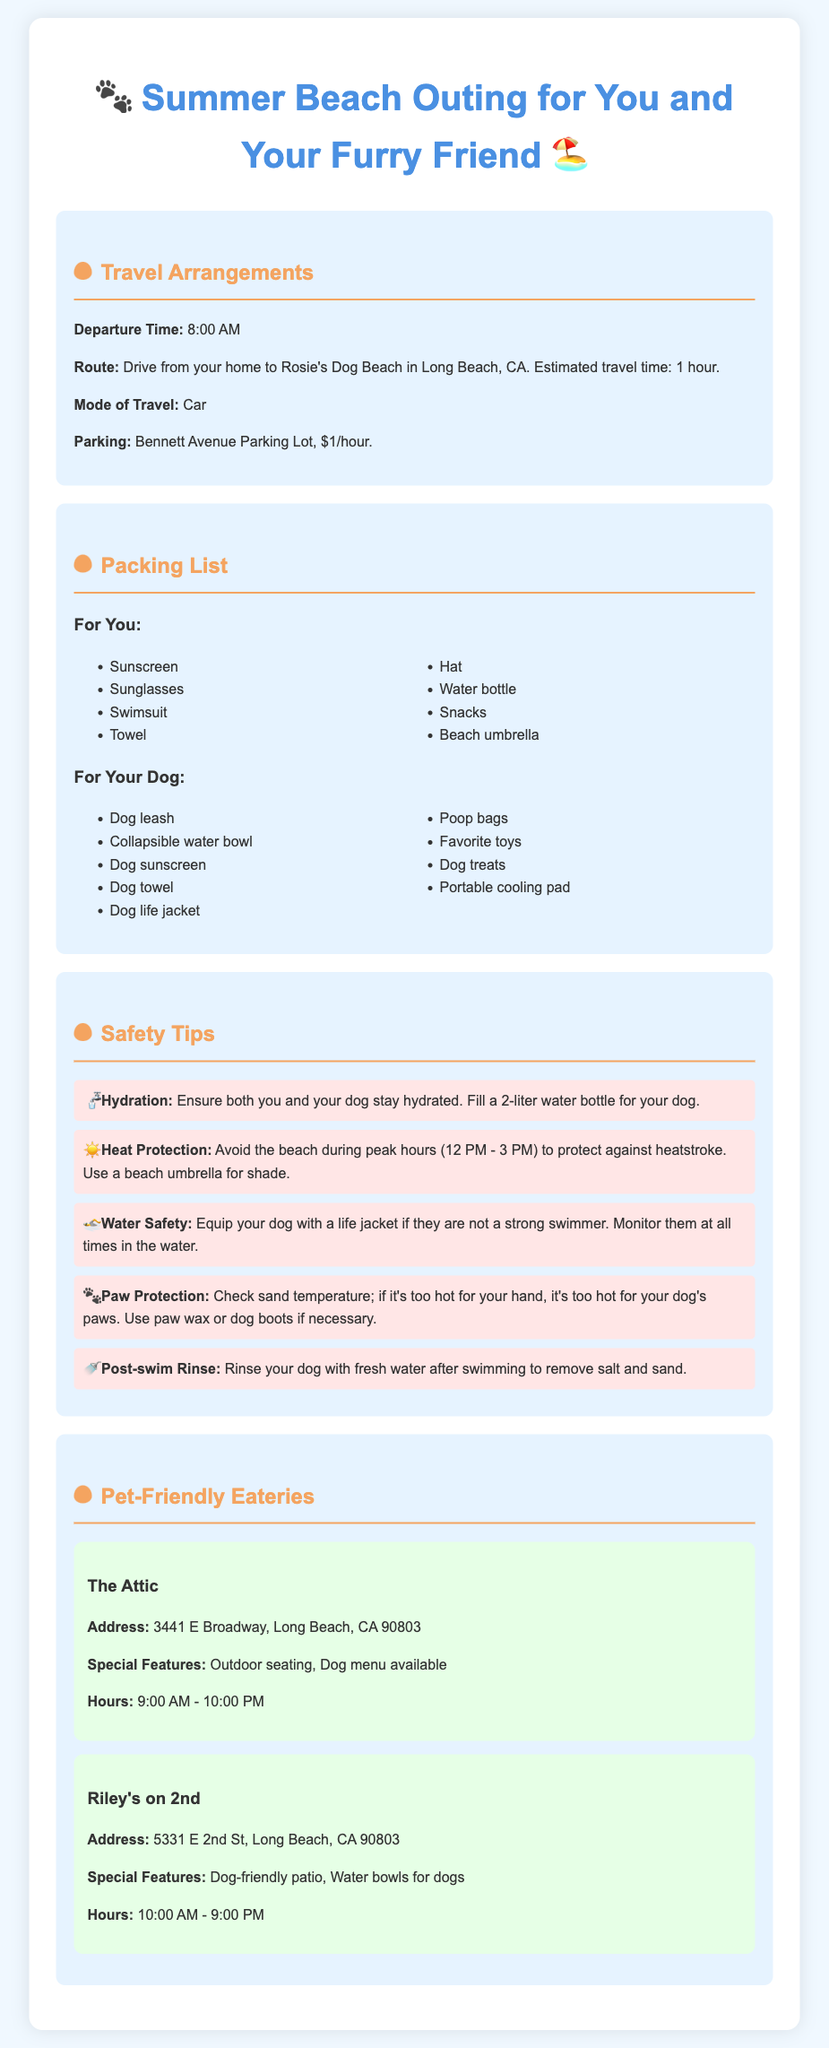What is the departure time for the outing? The document specifies the departure time as 8:00 AM.
Answer: 8:00 AM What is the estimated travel time to the beach? It states that the estimated travel time to Rosie's Dog Beach is 1 hour.
Answer: 1 hour What items are recommended for your dog? A bulleted list includes items like a dog leash, collapsible water bowl, and dog sunscreen, emphasizing their importance for the outing.
Answer: Dog leash, collapsible water bowl, dog sunscreen What is a safety tip regarding hydration? The document advises to ensure both the owner and dog stay hydrated by filling a 2-liter water bottle for the dog.
Answer: Fill a 2-liter water bottle for your dog What features does The Attic have for dogs? The Attic offers outdoor seating and a dog menu, tailored to enhance the experience for pet owners.
Answer: Outdoor seating, Dog menu available Why is using a beach umbrella recommended? It helps to protect against heatstroke by providing shade during peak hours at the beach.
Answer: To protect against heatstroke Which eatery has a dog-friendly patio? The document mentions Riley's on 2nd as having a dog-friendly patio with amenities like water bowls for dogs.
Answer: Riley's on 2nd What is the address of The Attic? The address for The Attic is listed clearly as 3441 E Broadway, Long Beach, CA 90803.
Answer: 3441 E Broadway, Long Beach, CA 90803 What should you do after your dog swims? It suggests rinsing your dog with fresh water to remove salt and sand after swimming.
Answer: Rinse with fresh water 